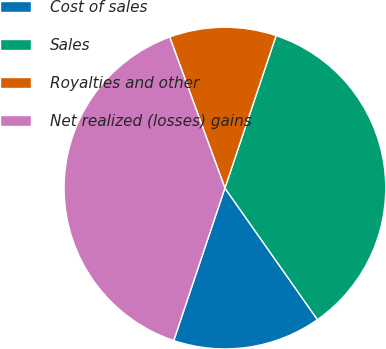Convert chart to OTSL. <chart><loc_0><loc_0><loc_500><loc_500><pie_chart><fcel>Cost of sales<fcel>Sales<fcel>Royalties and other<fcel>Net realized (losses) gains<nl><fcel>14.91%<fcel>35.09%<fcel>10.73%<fcel>39.27%<nl></chart> 